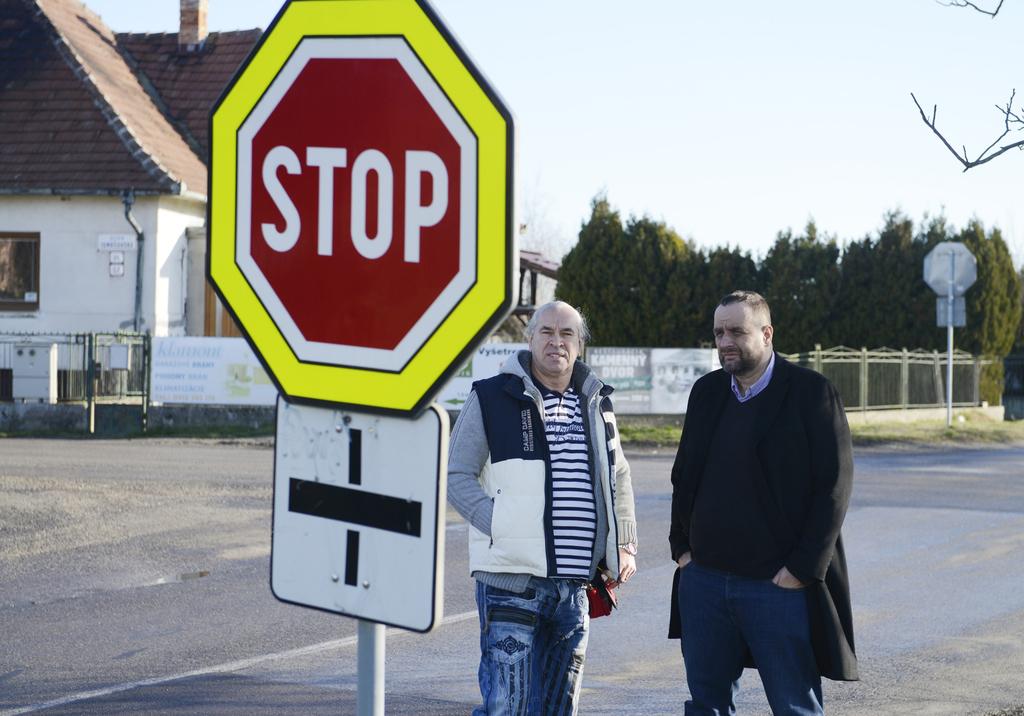What do vehicles have to do when they come up to the sign?
Ensure brevity in your answer.  Stop. 